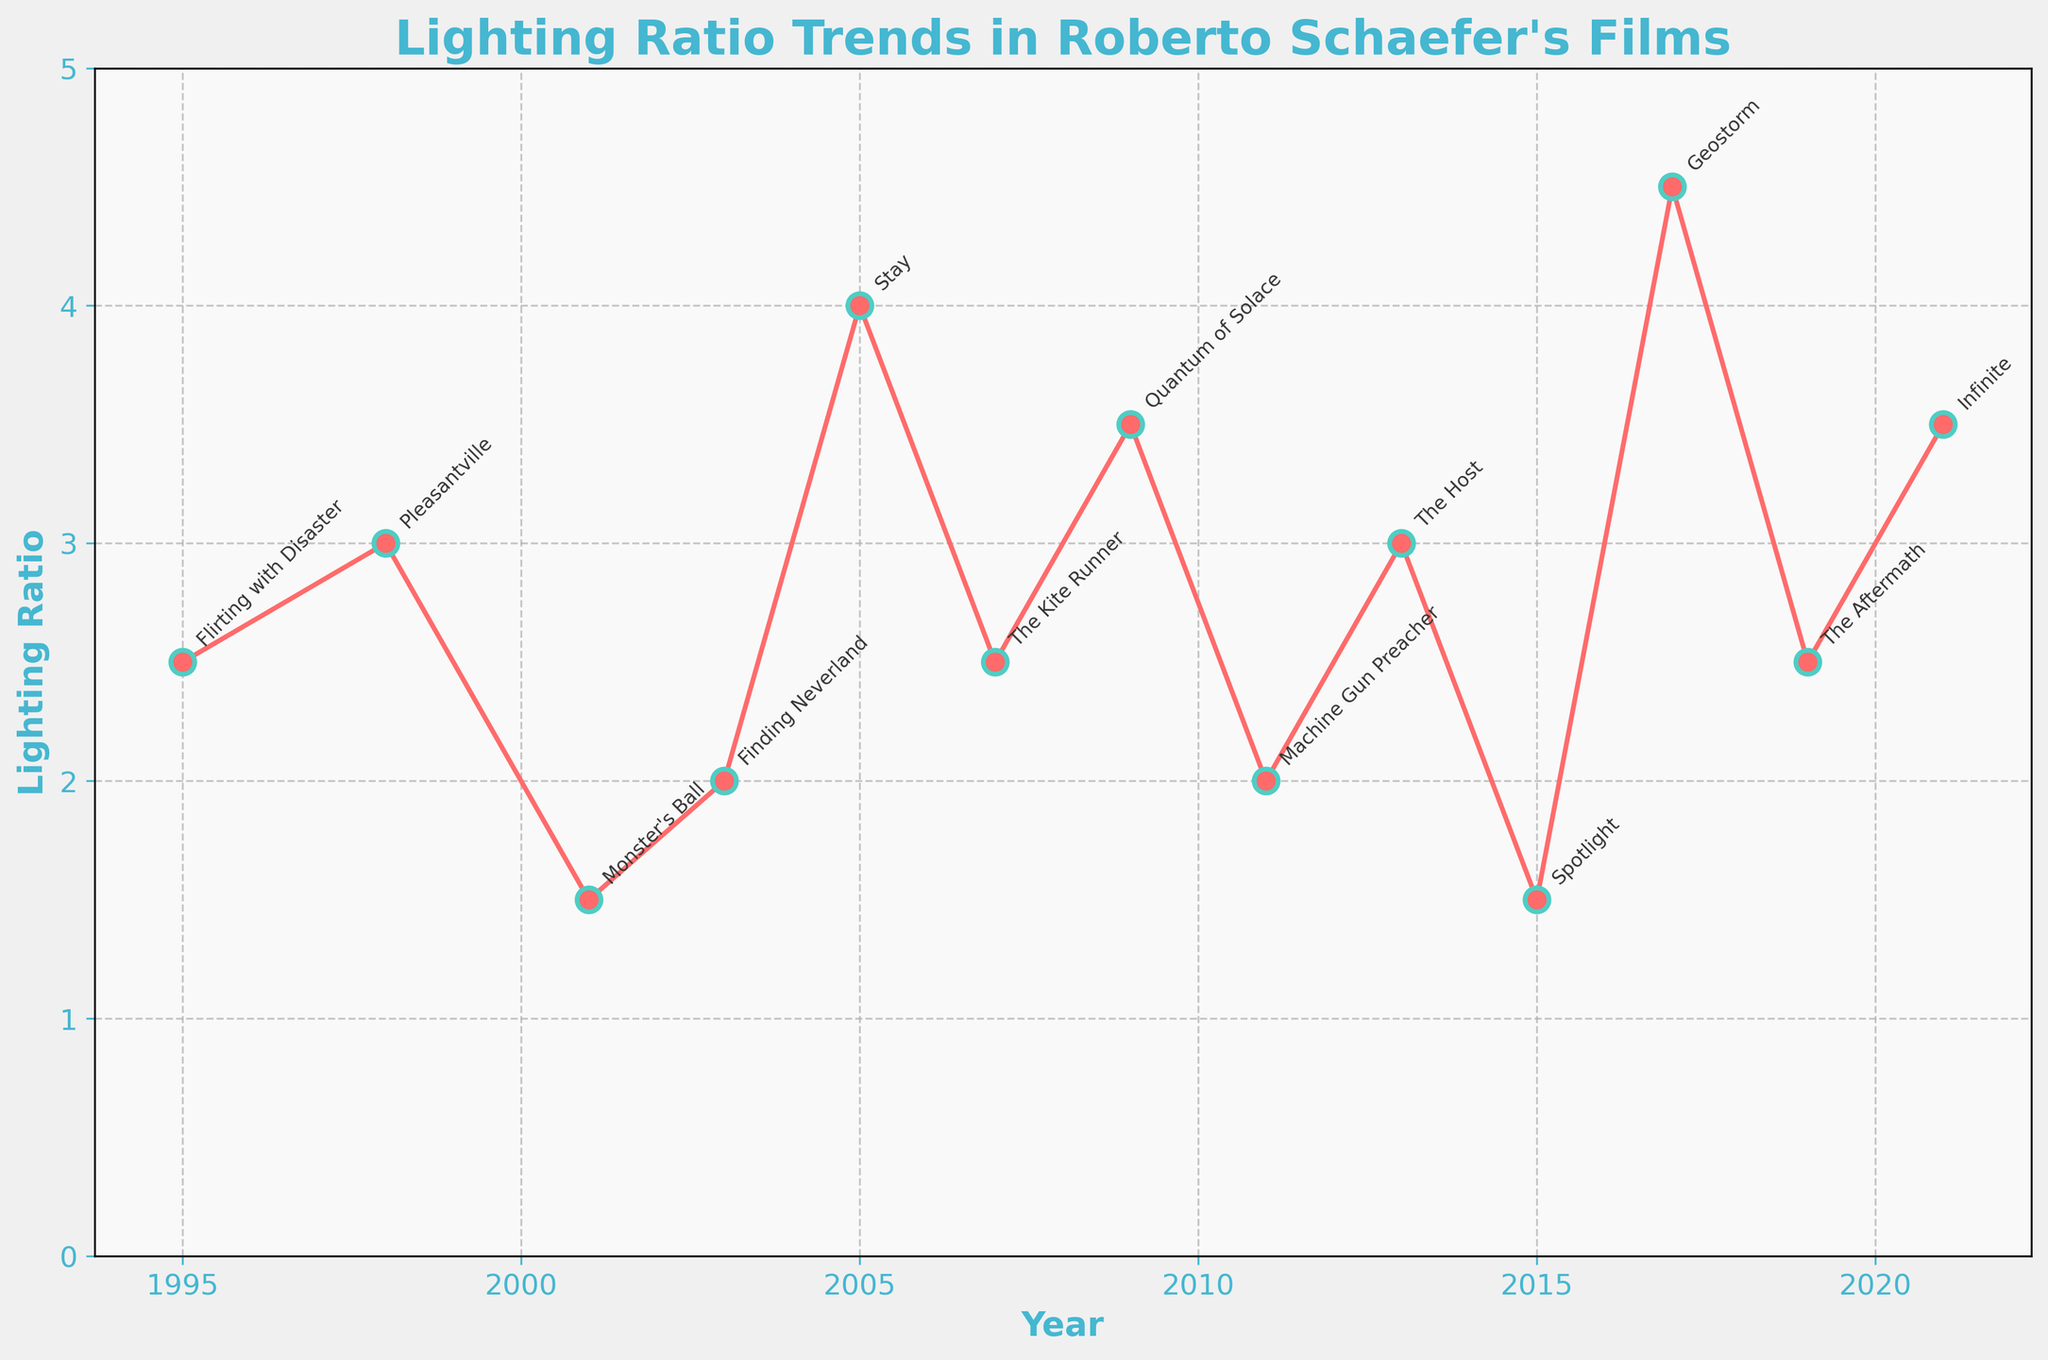What is the lighting ratio trend between "Pleasantville" in 1998 and "The Kite Runner" in 2007? To determine the trend between "Pleasantville" and "The Kite Runner," look at the years and corresponding lighting ratios. In 1998, "Pleasantville" has a lighting ratio of 3:1. In 2007, "The Kite Runner" has a lighting ratio of 2.5:1. The lighting ratio decreases from 3:1 to 2.5:1 over this period.
Answer: Decreasing Which film has the highest lighting ratio and what is that ratio? Look for the film with the highest point on the y-axis representing the lighting ratio. "Geostorm" in 2017 has the highest lighting ratio at 4.5:1.
Answer: Geostorm, 4.5:1 What is the difference in lighting ratios between "Stay" in 2005 and "Machine Gun Preacher" in 2011? Refer to the lighting ratios for both films. "Stay" has a ratio of 4:1, and "Machine Gun Preacher" has a ratio of 2:1. The difference is 4 - 2 = 2.
Answer: 2 Which films share the same lighting ratio and what is that ratio? Identify films with the same lighting ratio on the y-axis. "Flirting with Disaster" (1995) and "The Kite Runner" (2007) both share a ratio of 2.5:1. "Pleasantville" (1998) and "The Host" (2013) both share a ratio of 3:1. "Monster's Ball" (2001) and "Spotlight" (2015) both share a ratio of 1.5:1.
Answer: "Flirting with Disaster" and "The Kite Runner" both have 2.5:1; "Pleasantville" and "The Host" both have 3:1; "Monster's Ball" and "Spotlight" both have 1.5:1 What is the average lighting ratio for all the films in the dataset? Calculate the average by summing all the lighting ratios and dividing by the number of films. The ratios are 2.5, 3, 1.5, 2, 4, 2.5, 3.5, 2, 3, 1.5, 4.5, 2.5, 3.5. The sum is 34.5, divided by 13 films, gives an average of 34.5/13 = 2.65.
Answer: 2.65 How did the lighting ratio change from "Quantum of Solace" in 2009 to "The Host" in 2013? Check the lighting ratios for both films. "Quantum of Solace" has a ratio of 3.5:1, and "The Host" has a ratio of 3:1. The ratio decreases from 3.5:1 to 3:1.
Answer: Decrease Which film follows "Stay" in 2005 in terms of lighting ratio and what is the trend? The film following "Stay" in terms of lighting ratio is "The Kite Runner" in 2007, which moves from 4:1 in "Stay" to 2.5:1 in "The Kite Runner." This is a decreasing trend.
Answer: The Kite Runner, decreasing What is the range of lighting ratios used across Roberto Schaefer’s films? Identify the minimum and maximum values of lighting ratios. The minimum ratio is 1.5:1, and the maximum ratio is 4.5:1. The range is 4.5 - 1.5 = 3.
Answer: 3 What films used the lighting ratio of 3.5:1? Look for films marked at 3.5 on the y-axis. "Quantum of Solace" (2009) and "Infinite" (2021) both have a lighting ratio of 3.5:1.
Answer: Quantum of Solace, Infinite 